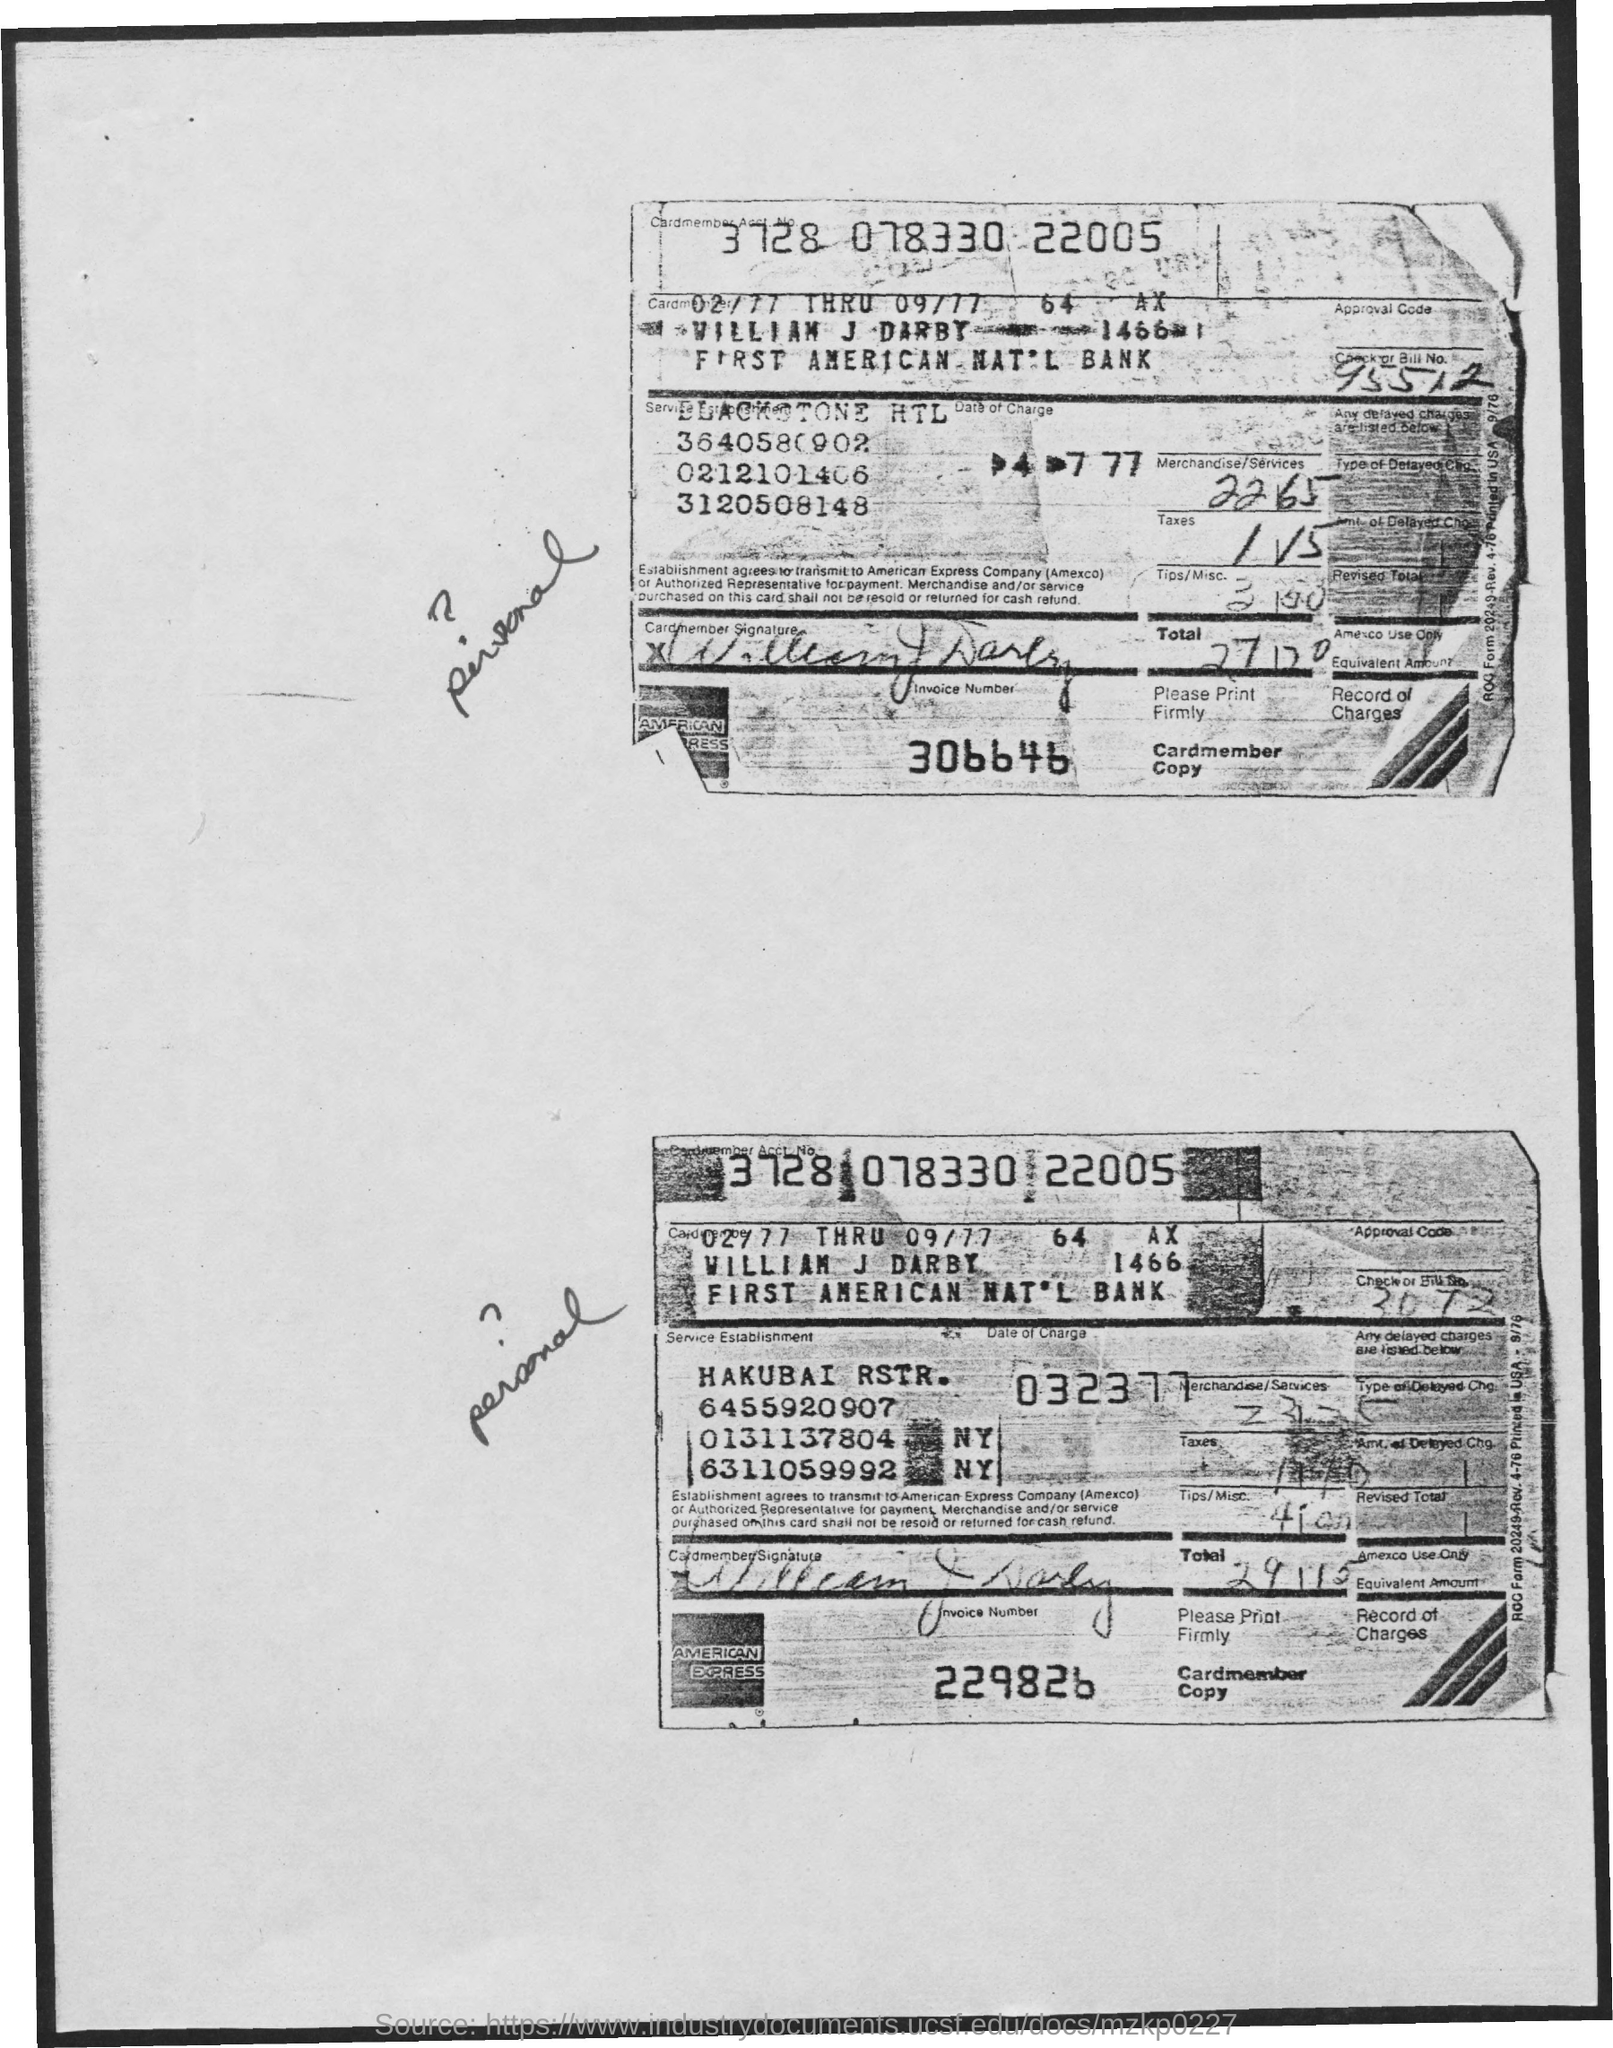What is the invoice number in the first copy from the top?
Ensure brevity in your answer.  306646. What is the check or bill no. in the first copy from the top?
Your response must be concise. 95512. What is the cardmember acct. no.?
Provide a short and direct response. 3728 078330 22005. Who is the cardmember?
Provide a succinct answer. William J Darby. 